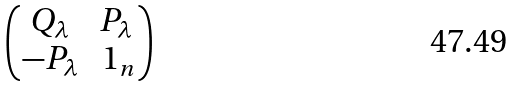<formula> <loc_0><loc_0><loc_500><loc_500>\begin{pmatrix} Q _ { \lambda } & P _ { \lambda } \\ - P _ { \lambda } & \ 1 _ { n } \end{pmatrix}</formula> 